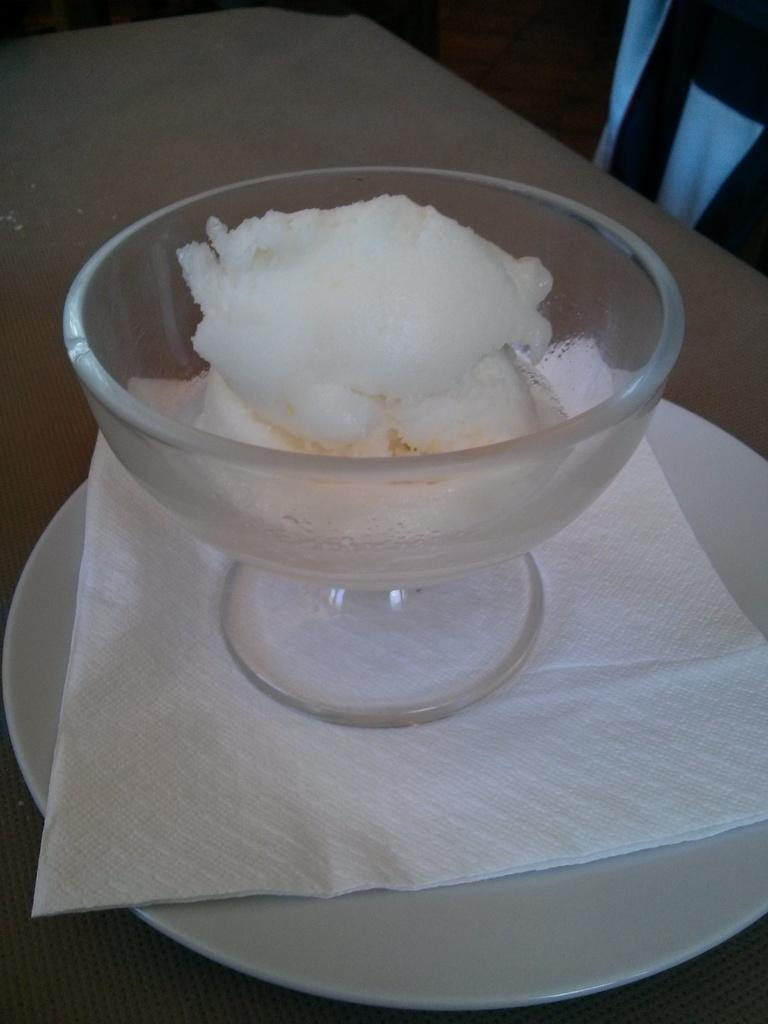Could you give a brief overview of what you see in this image? In this picture we can see food in the bowl and this bowl and a tissue paper in the plate, here we can see this plate is on the platform. 